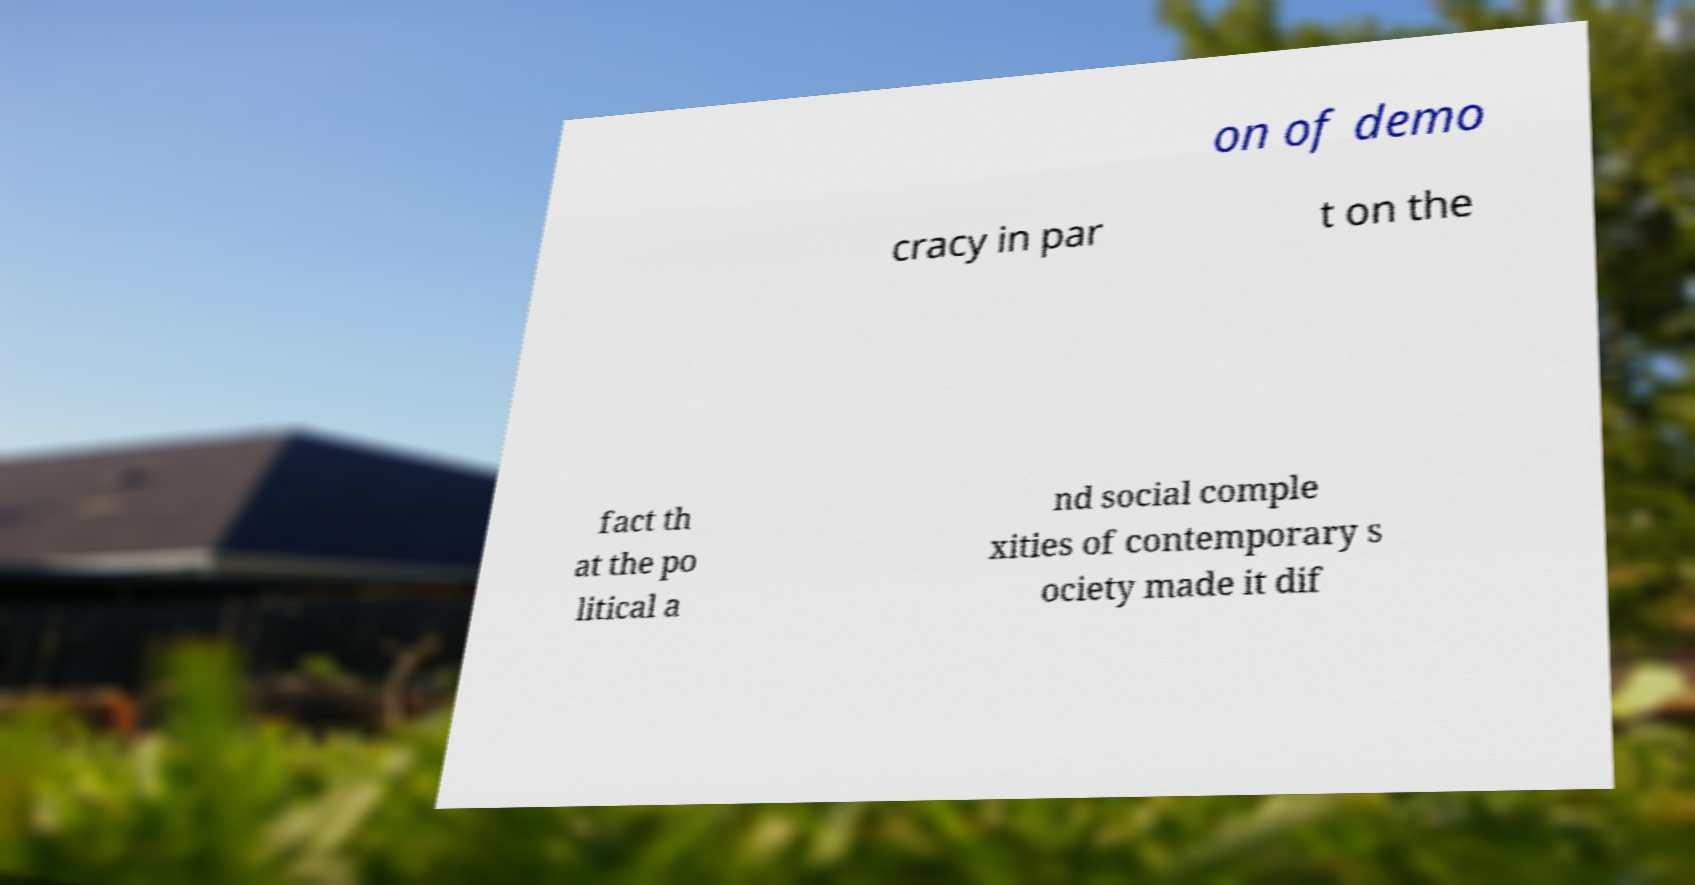Please identify and transcribe the text found in this image. on of demo cracy in par t on the fact th at the po litical a nd social comple xities of contemporary s ociety made it dif 